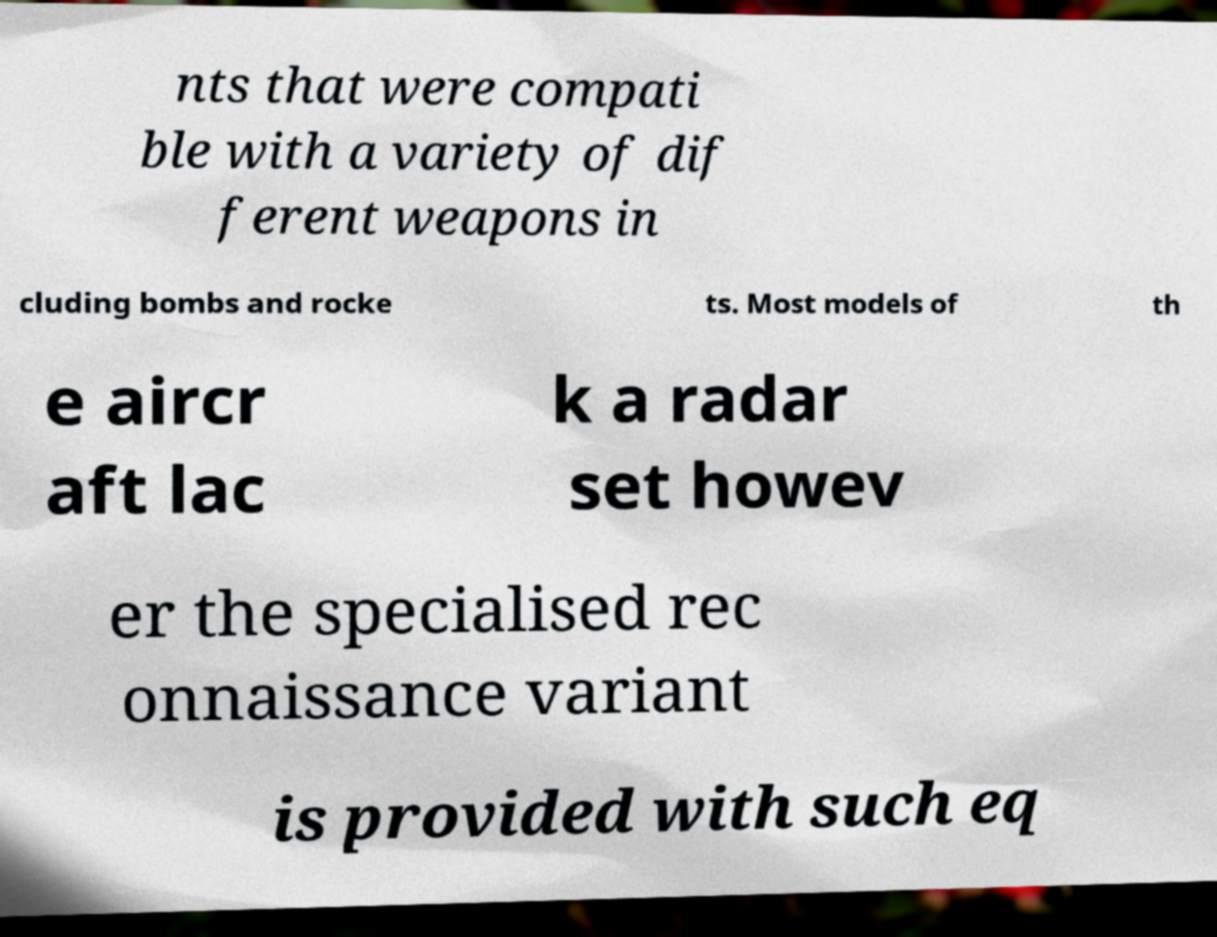Can you accurately transcribe the text from the provided image for me? nts that were compati ble with a variety of dif ferent weapons in cluding bombs and rocke ts. Most models of th e aircr aft lac k a radar set howev er the specialised rec onnaissance variant is provided with such eq 